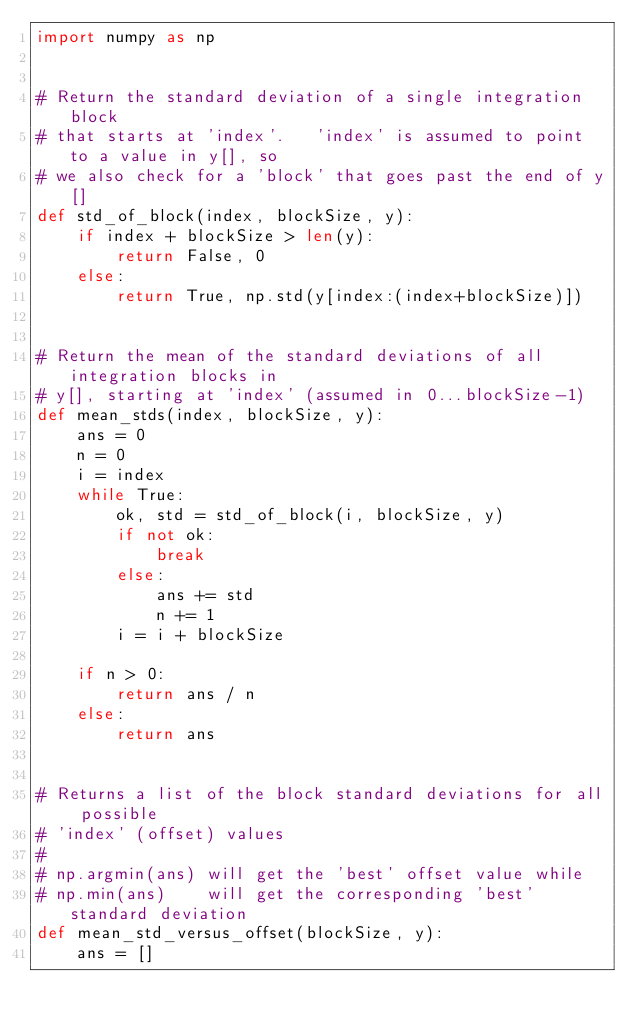<code> <loc_0><loc_0><loc_500><loc_500><_Python_>import numpy as np


# Return the standard deviation of a single integration block
# that starts at 'index'.   'index' is assumed to point to a value in y[], so
# we also check for a 'block' that goes past the end of y[]
def std_of_block(index, blockSize, y):
    if index + blockSize > len(y):
        return False, 0
    else:
        return True, np.std(y[index:(index+blockSize)])


# Return the mean of the standard deviations of all integration blocks in
# y[], starting at 'index' (assumed in 0...blockSize-1)
def mean_stds(index, blockSize, y):
    ans = 0
    n = 0
    i = index
    while True:
        ok, std = std_of_block(i, blockSize, y)
        if not ok:
            break
        else:
            ans += std
            n += 1
        i = i + blockSize

    if n > 0:
        return ans / n
    else:
        return ans


# Returns a list of the block standard deviations for all possible
# 'index' (offset) values
#
# np.argmin(ans) will get the 'best' offset value while
# np.min(ans)    will get the corresponding 'best' standard deviation
def mean_std_versus_offset(blockSize, y):
    ans = []</code> 